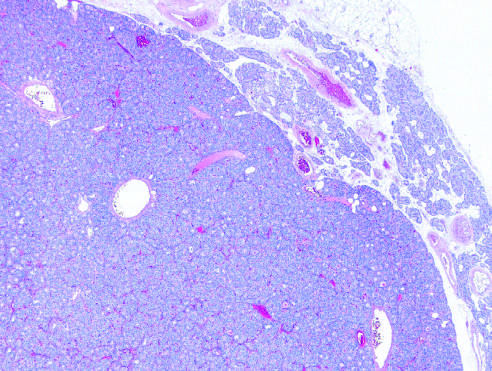what is a solitary hypercellular adenoma delineated from?
Answer the question using a single word or phrase. The residual normocellular gland on the upper right 